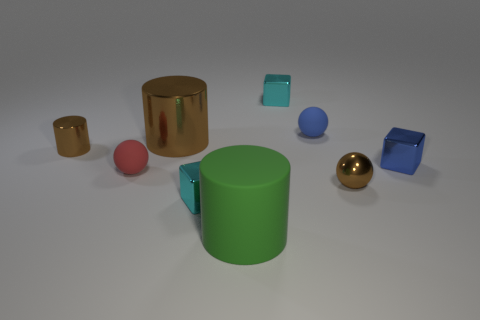What time of day does the lighting in the scene suggest? The lighting in the scene is soft and diffused with no hard shadows or bright highlights, suggesting an overcast sky or indoor lighting rather than direct sunlight. It's difficult to determine the time of day precisely, but the ambient lighting would be consistent with daylight hours in an indoor setting with artificial lighting. 